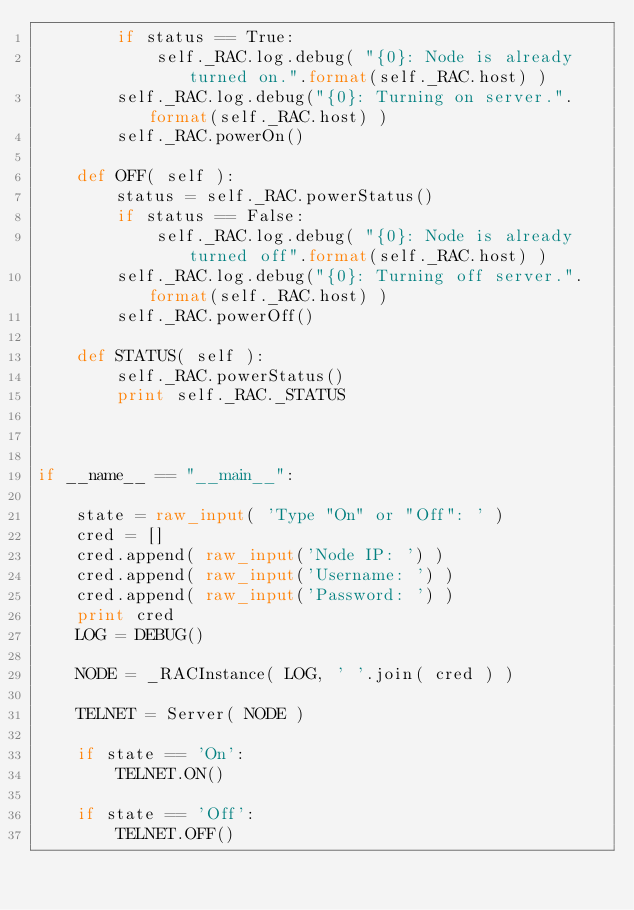<code> <loc_0><loc_0><loc_500><loc_500><_Python_>        if status == True:
            self._RAC.log.debug( "{0}: Node is already turned on.".format(self._RAC.host) )
        self._RAC.log.debug("{0}: Turning on server.".format(self._RAC.host) )
        self._RAC.powerOn()

    def OFF( self ):
        status = self._RAC.powerStatus()
        if status == False:
            self._RAC.log.debug( "{0}: Node is already turned off".format(self._RAC.host) )
        self._RAC.log.debug("{0}: Turning off server.".format(self._RAC.host) )
        self._RAC.powerOff()

    def STATUS( self ):
        self._RAC.powerStatus()
        print self._RAC._STATUS



if __name__ == "__main__":
    
    state = raw_input( 'Type "On" or "Off": ' )
    cred = []
    cred.append( raw_input('Node IP: ') )
    cred.append( raw_input('Username: ') )
    cred.append( raw_input('Password: ') )
    print cred
    LOG = DEBUG()

    NODE = _RACInstance( LOG, ' '.join( cred ) )
    
    TELNET = Server( NODE )
    
    if state == 'On':
        TELNET.ON()

    if state == 'Off':
        TELNET.OFF()
</code> 